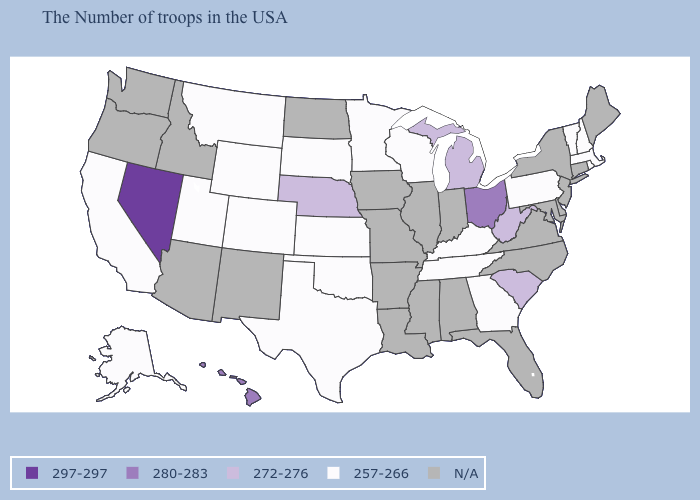What is the value of Rhode Island?
Short answer required. 257-266. What is the value of Utah?
Quick response, please. 257-266. Among the states that border Iowa , does Nebraska have the highest value?
Quick response, please. Yes. Does Georgia have the highest value in the USA?
Keep it brief. No. Among the states that border West Virginia , which have the highest value?
Be succinct. Ohio. What is the value of Indiana?
Concise answer only. N/A. What is the lowest value in states that border New Jersey?
Give a very brief answer. 257-266. Name the states that have a value in the range 297-297?
Give a very brief answer. Nevada. Does the map have missing data?
Short answer required. Yes. What is the lowest value in the USA?
Quick response, please. 257-266. Name the states that have a value in the range 257-266?
Short answer required. Massachusetts, Rhode Island, New Hampshire, Vermont, Pennsylvania, Georgia, Kentucky, Tennessee, Wisconsin, Minnesota, Kansas, Oklahoma, Texas, South Dakota, Wyoming, Colorado, Utah, Montana, California, Alaska. 